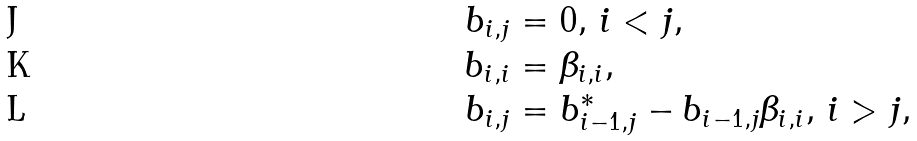<formula> <loc_0><loc_0><loc_500><loc_500>b _ { i , j } & = 0 , \, i < j , \\ b _ { i , i } & = \beta _ { i , i } , \\ b _ { i , j } & = b _ { i - 1 , j } ^ { \ast } - b _ { i - 1 , j } \beta _ { i , i } , \, i > j ,</formula> 